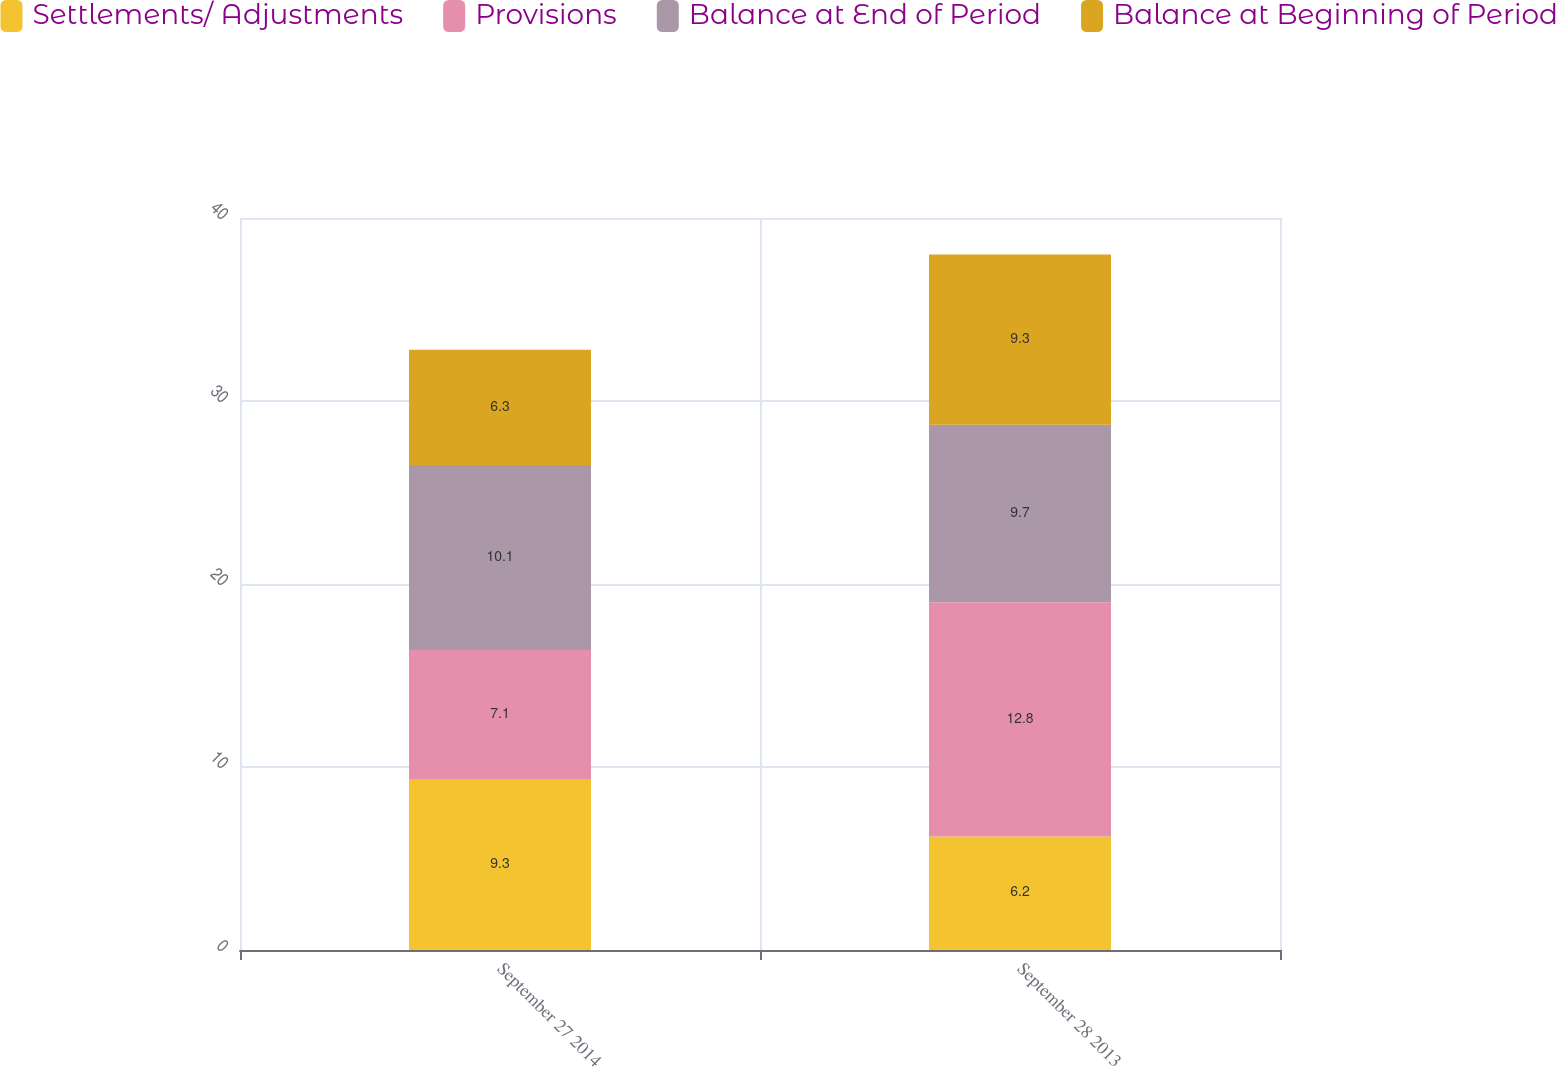Convert chart to OTSL. <chart><loc_0><loc_0><loc_500><loc_500><stacked_bar_chart><ecel><fcel>September 27 2014<fcel>September 28 2013<nl><fcel>Settlements/ Adjustments<fcel>9.3<fcel>6.2<nl><fcel>Provisions<fcel>7.1<fcel>12.8<nl><fcel>Balance at End of Period<fcel>10.1<fcel>9.7<nl><fcel>Balance at Beginning of Period<fcel>6.3<fcel>9.3<nl></chart> 